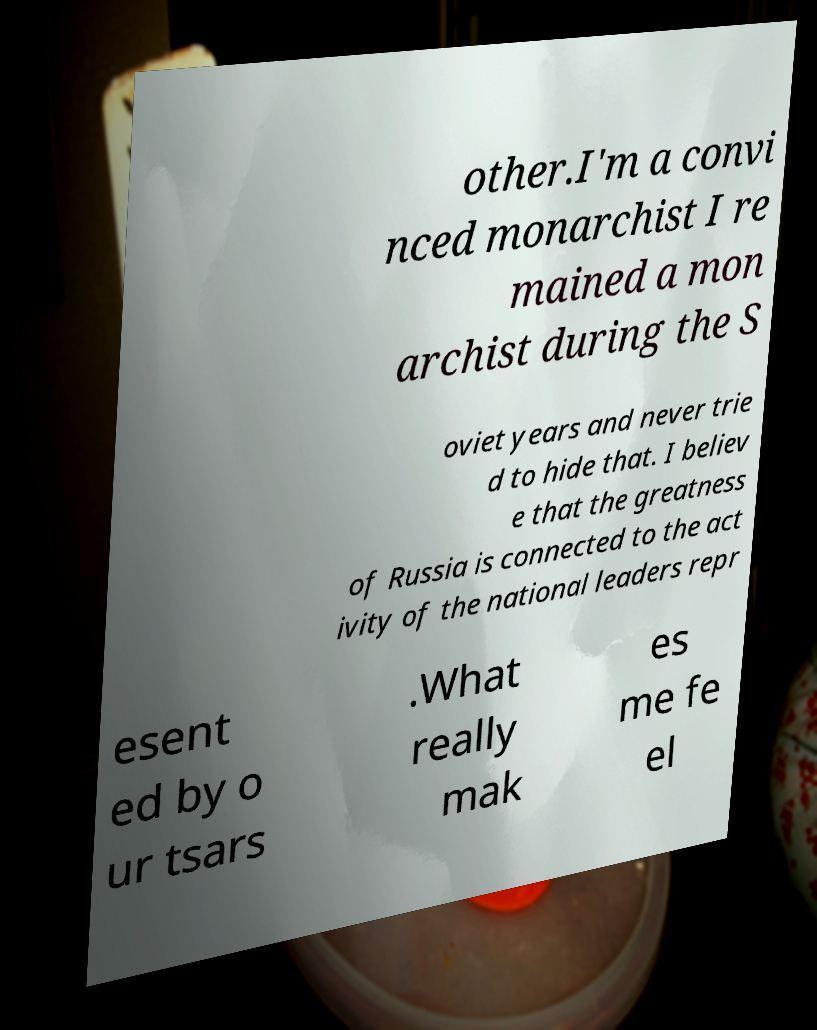There's text embedded in this image that I need extracted. Can you transcribe it verbatim? other.I'm a convi nced monarchist I re mained a mon archist during the S oviet years and never trie d to hide that. I believ e that the greatness of Russia is connected to the act ivity of the national leaders repr esent ed by o ur tsars .What really mak es me fe el 